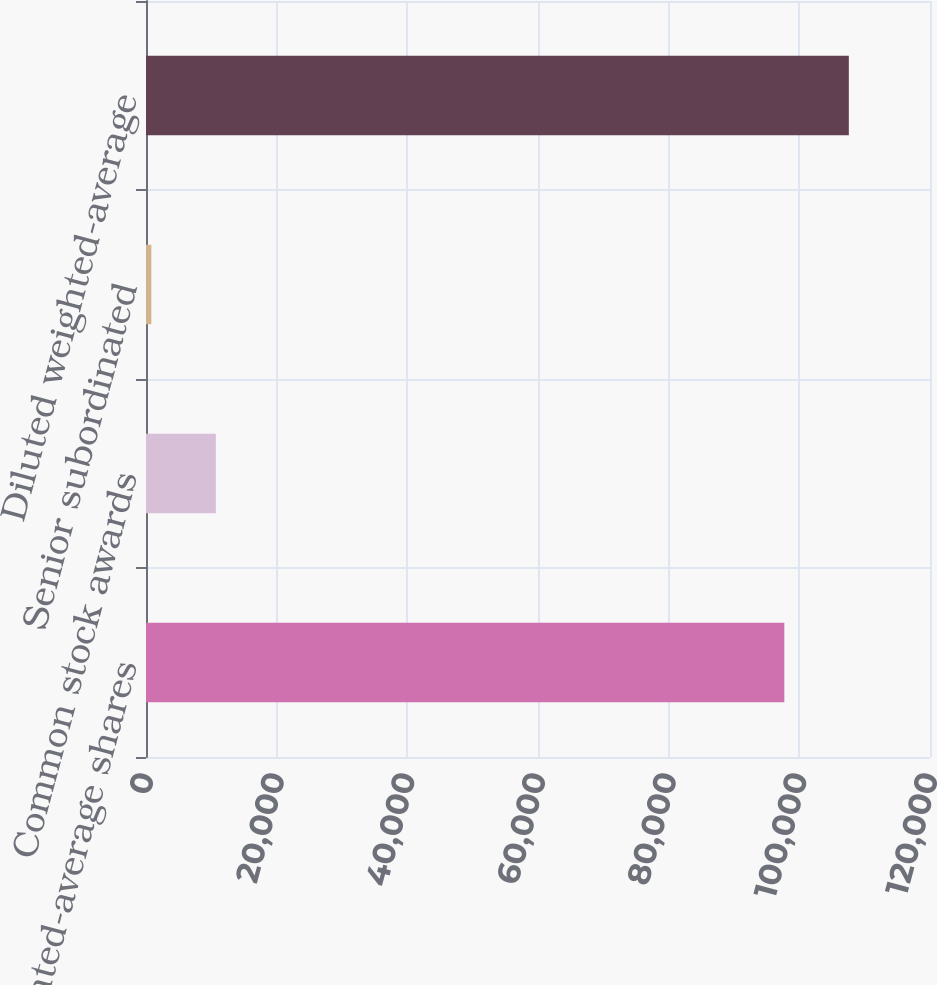<chart> <loc_0><loc_0><loc_500><loc_500><bar_chart><fcel>Basic weighted-average shares<fcel>Common stock awards<fcel>Senior subordinated<fcel>Diluted weighted-average<nl><fcel>97702<fcel>10690.2<fcel>816<fcel>107576<nl></chart> 